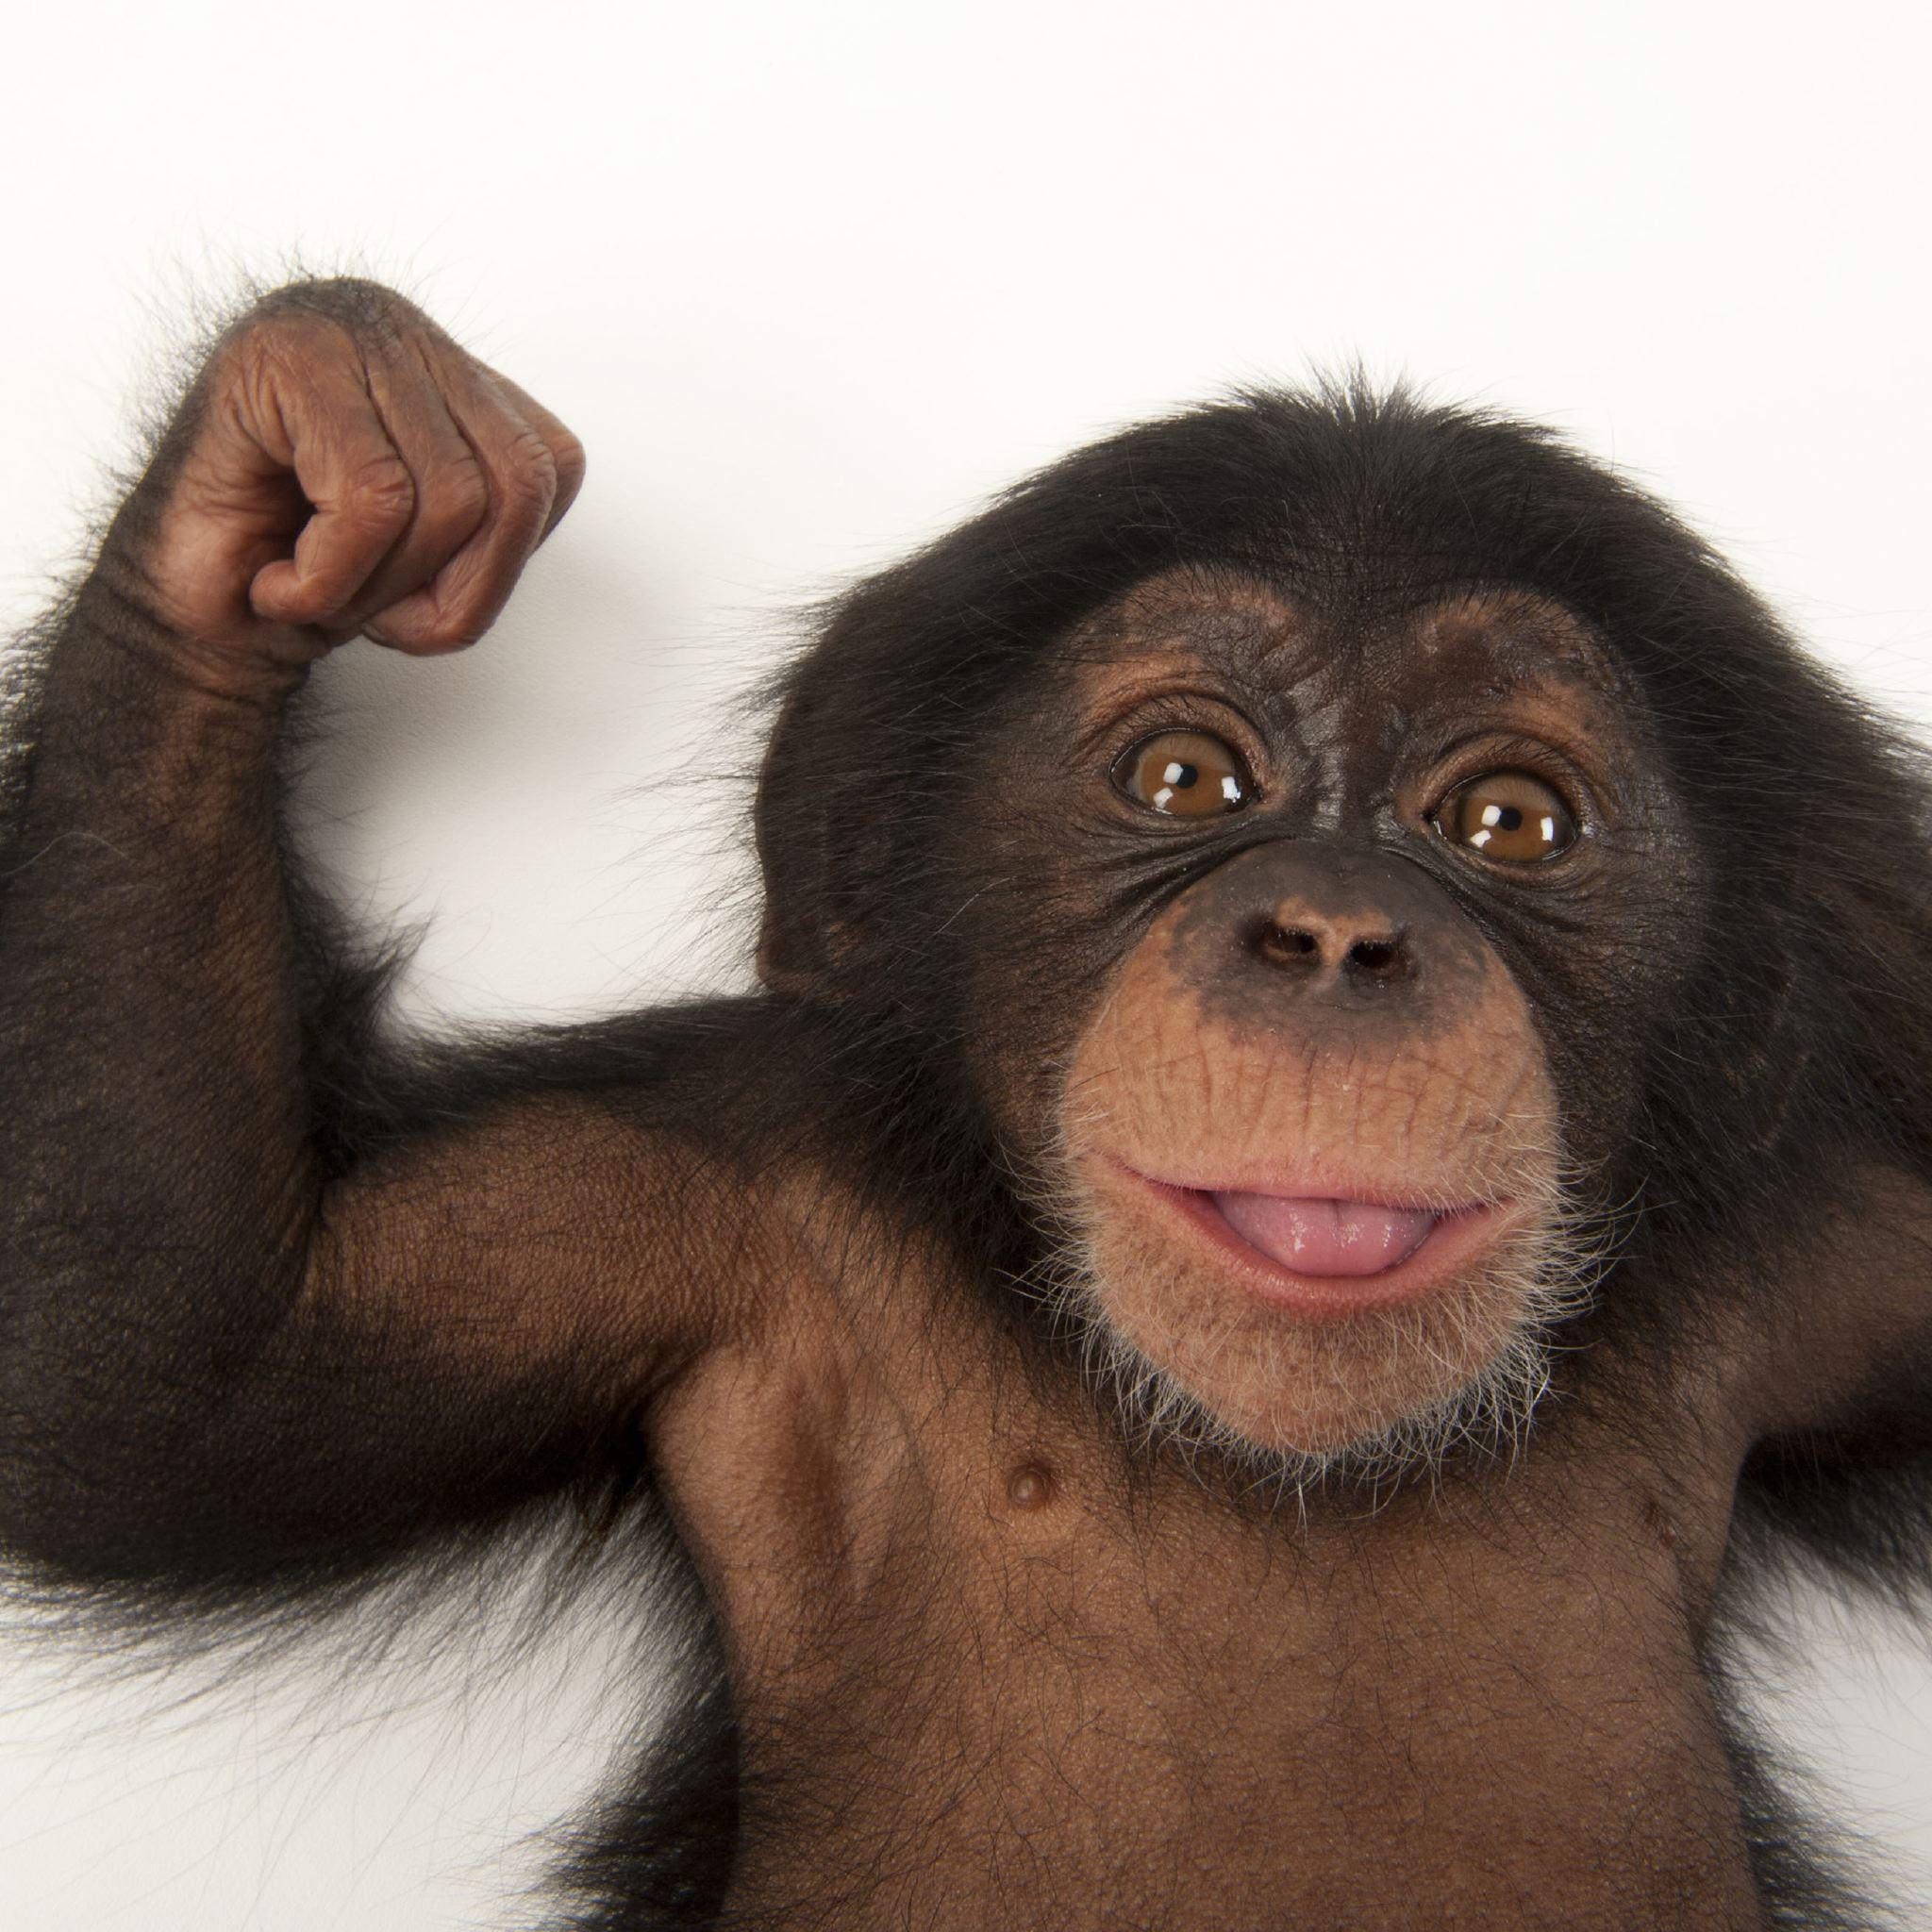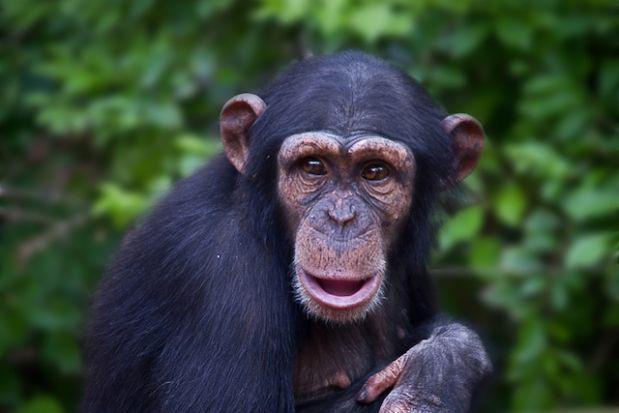The first image is the image on the left, the second image is the image on the right. For the images shown, is this caption "One monkey is holding another in one of the images." true? Answer yes or no. No. 